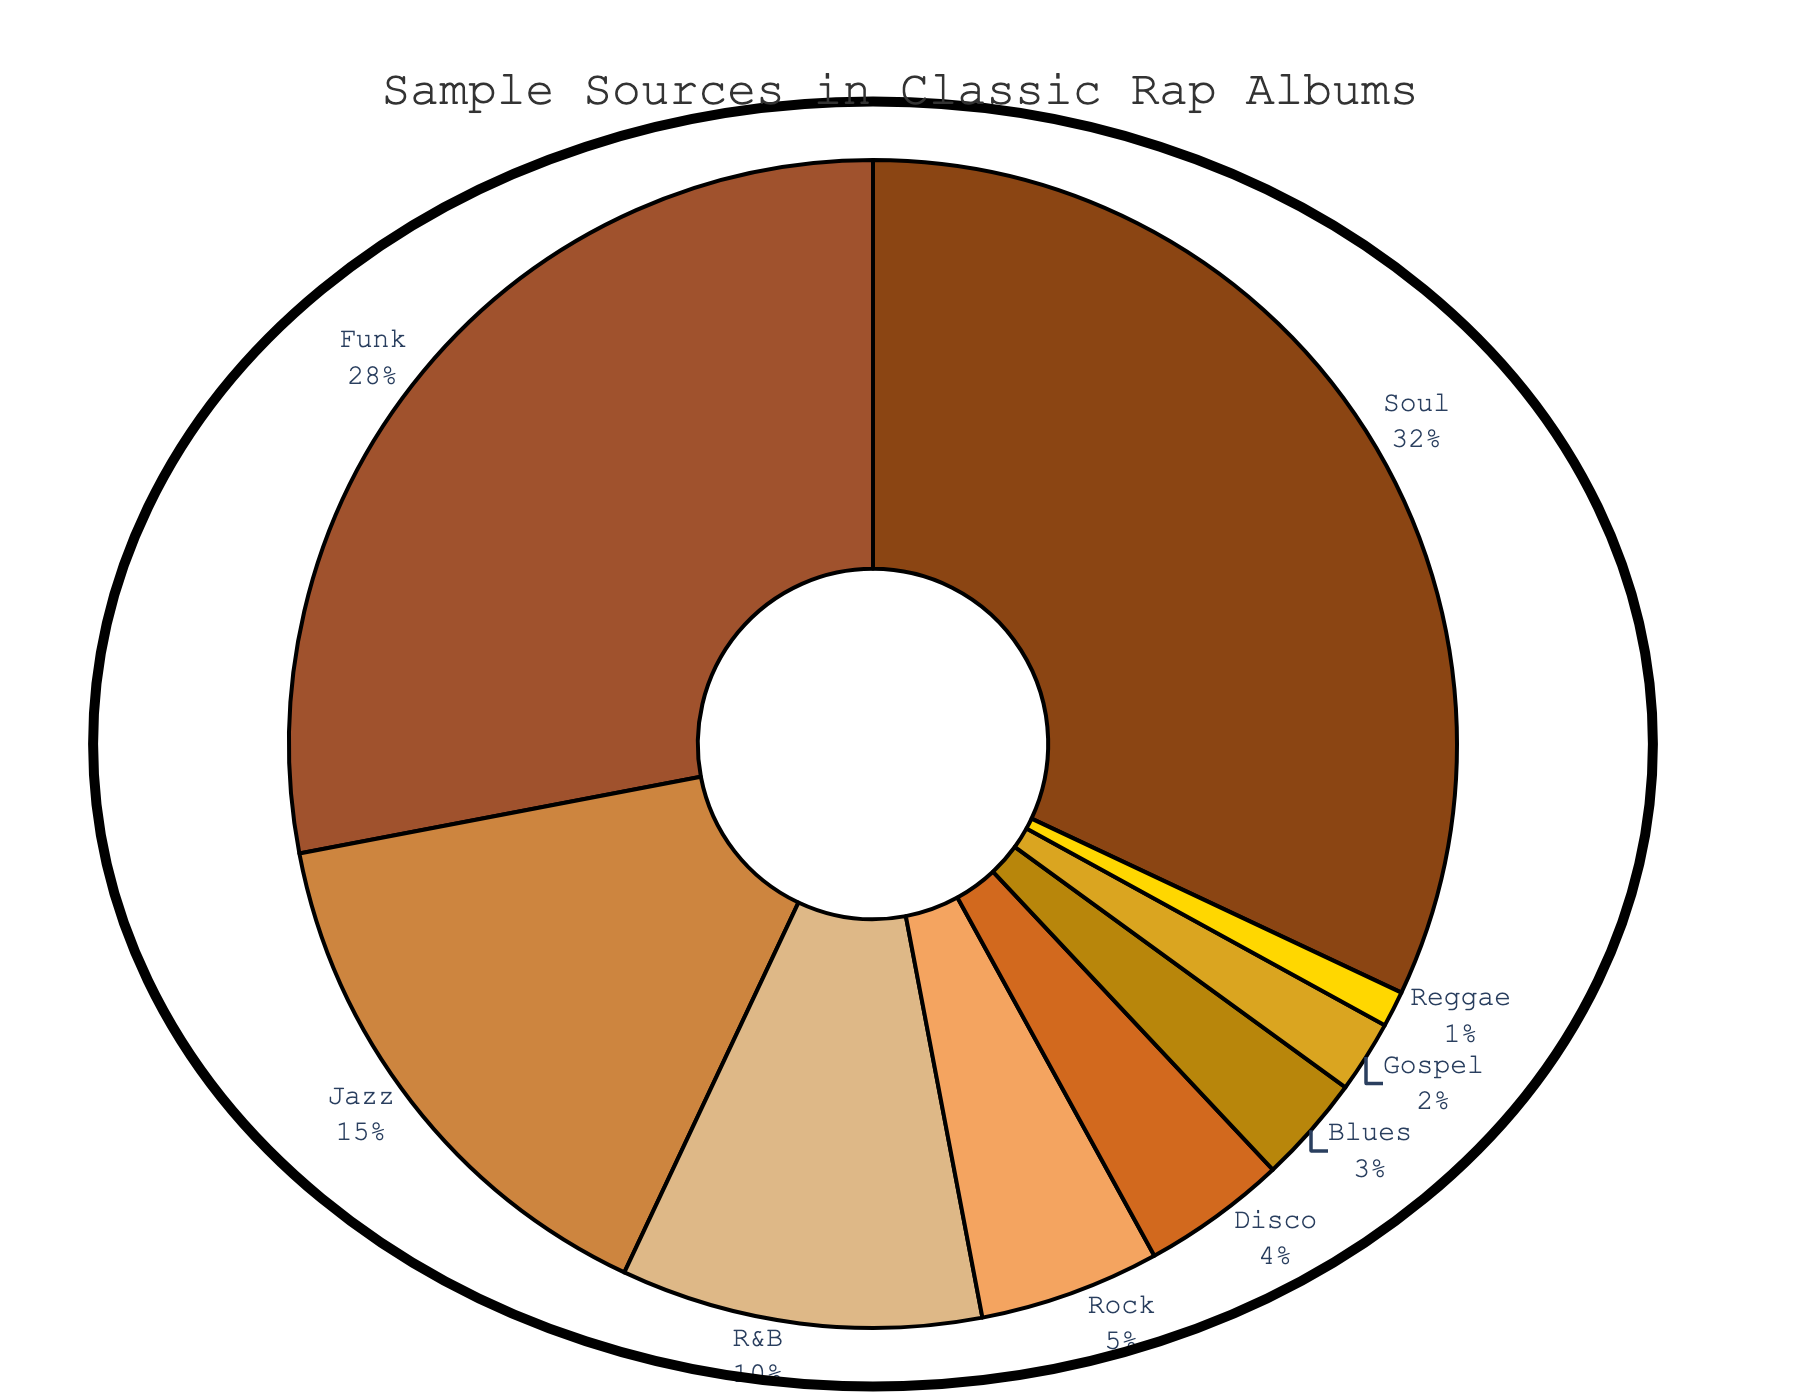What's the most common sample source used in classic rap albums? To determine the most common sample source, we look at the segment with the largest percentage. The Soul genre occupies the largest slice in the pie chart with 32%.
Answer: Soul How much more prevalent is Soul compared to Rock in the sample sources? The percentage for Soul is 32% and for Rock it is 5%. To find how much more prevalent Soul is, we subtract the percentage of Rock from that of Soul (32% - 5%).
Answer: 27% Which three genres have the smallest contributions to the sample sources? We identify the three smallest segments by looking at the percentages: Gospel (2%), Reggae (1%), and Blues (3%). These three are the smallest contributors.
Answer: Gospel, Reggae, Blues What is the combined percentage of Funk and Jazz samples used in classic rap albums? To find the combined percentage, we simply add the percentages of Funk and Jazz. Funk has 28% and Jazz has 15%. Thus, 28% + 15% equals 43%.
Answer: 43% By what percentage is Funk more prevalent than R&B in the sample sources? We determine the difference between Funk and R&B by subtracting the percentage of R&B from Funk. Funk is 28% and R&B is 10%, so 28% - 10% is 18%.
Answer: 18% If we group Soul, Funk, and Jazz together, what percentage of the total sample sources do they constitute? We add the percentages of Soul, Funk, and Jazz. Soul is 32%, Funk is 28%, and Jazz is 15%. Adding these together results in 32% + 28% + 15%, which is 75%.
Answer: 75% How does the percentage of Disco compare to the sum of Blues and Gospel? Disco has a percentage of 4%. The sum of Blues and Gospel is calculated by adding 3% (Blues) and 2% (Gospel) to get 5%. Comparing these, Disco (4%) is less than the sum of Blues and Gospel (5%).
Answer: Less What is the visual characteristic that highlights the most common sample source? The most common sample source is Soul, which is represented by the largest segment of the pie chart. It occupies the largest area, making it visually prominent.
Answer: Largest segment Which genre has a near-equal percentage to the combined percentage of Gospel and Blues? Blues has 3% and Gospel has 2%. Their combined percentage is 3% + 2% = 5%. The genre Rock also has a percentage of 5%, which is equal to the combined percentage of Gospel and Blues.
Answer: Rock What is the relative contribution of Reggae compared to the total percentage of Soul, Funk, Jazz, and R&B? First, sum the percentages of Soul (32%), Funk (28%), Jazz (15%), and R&B (10%) to get 85%. Reggae is 1%, so the relative contribution is (1/85) * 100 ≈ 1.18%.
Answer: 1.18% 